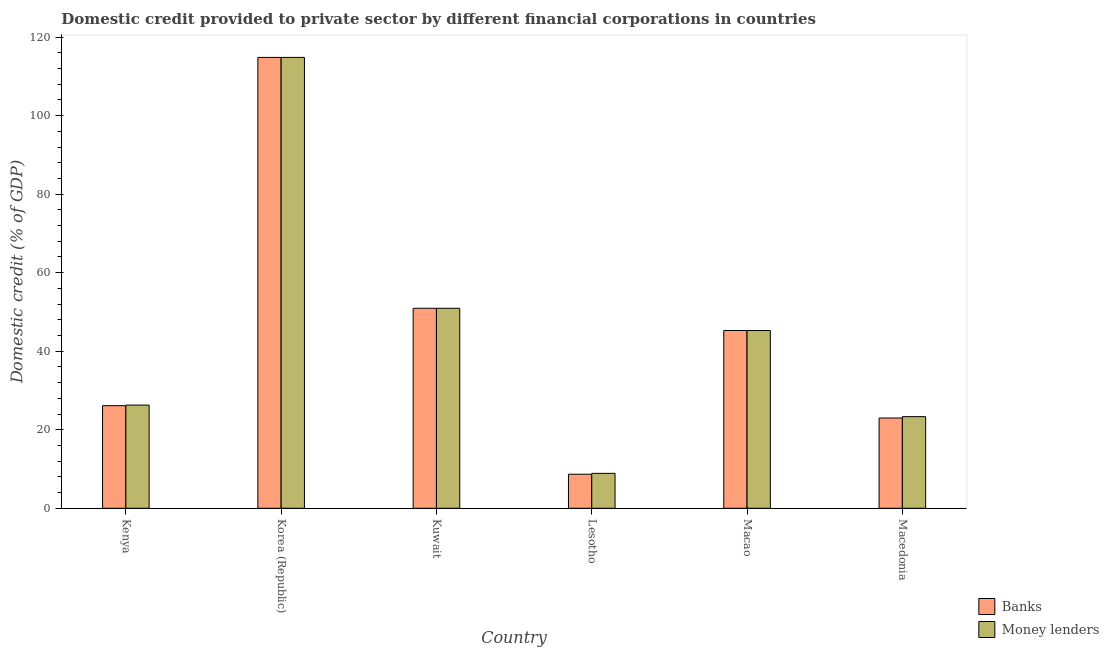How many different coloured bars are there?
Offer a very short reply. 2. Are the number of bars per tick equal to the number of legend labels?
Provide a short and direct response. Yes. Are the number of bars on each tick of the X-axis equal?
Provide a succinct answer. Yes. How many bars are there on the 4th tick from the right?
Your answer should be compact. 2. What is the label of the 5th group of bars from the left?
Give a very brief answer. Macao. What is the domestic credit provided by banks in Kenya?
Your response must be concise. 26.13. Across all countries, what is the maximum domestic credit provided by money lenders?
Provide a short and direct response. 114.82. Across all countries, what is the minimum domestic credit provided by money lenders?
Give a very brief answer. 8.89. In which country was the domestic credit provided by money lenders maximum?
Keep it short and to the point. Korea (Republic). In which country was the domestic credit provided by banks minimum?
Give a very brief answer. Lesotho. What is the total domestic credit provided by banks in the graph?
Provide a succinct answer. 268.81. What is the difference between the domestic credit provided by banks in Kenya and that in Macao?
Your answer should be very brief. -19.14. What is the difference between the domestic credit provided by money lenders in Kenya and the domestic credit provided by banks in Kuwait?
Keep it short and to the point. -24.66. What is the average domestic credit provided by money lenders per country?
Your answer should be very brief. 44.92. In how many countries, is the domestic credit provided by money lenders greater than 80 %?
Provide a succinct answer. 1. What is the ratio of the domestic credit provided by banks in Lesotho to that in Macao?
Offer a very short reply. 0.19. Is the domestic credit provided by banks in Kuwait less than that in Macao?
Your answer should be compact. No. What is the difference between the highest and the second highest domestic credit provided by money lenders?
Your answer should be compact. 63.89. What is the difference between the highest and the lowest domestic credit provided by money lenders?
Provide a short and direct response. 105.93. In how many countries, is the domestic credit provided by money lenders greater than the average domestic credit provided by money lenders taken over all countries?
Your response must be concise. 3. What does the 2nd bar from the left in Lesotho represents?
Offer a terse response. Money lenders. What does the 2nd bar from the right in Macao represents?
Your answer should be very brief. Banks. What is the difference between two consecutive major ticks on the Y-axis?
Offer a very short reply. 20. Are the values on the major ticks of Y-axis written in scientific E-notation?
Your answer should be very brief. No. What is the title of the graph?
Keep it short and to the point. Domestic credit provided to private sector by different financial corporations in countries. What is the label or title of the X-axis?
Give a very brief answer. Country. What is the label or title of the Y-axis?
Offer a very short reply. Domestic credit (% of GDP). What is the Domestic credit (% of GDP) in Banks in Kenya?
Your answer should be very brief. 26.13. What is the Domestic credit (% of GDP) of Money lenders in Kenya?
Your answer should be compact. 26.28. What is the Domestic credit (% of GDP) in Banks in Korea (Republic)?
Provide a short and direct response. 114.82. What is the Domestic credit (% of GDP) of Money lenders in Korea (Republic)?
Your answer should be very brief. 114.82. What is the Domestic credit (% of GDP) of Banks in Kuwait?
Your answer should be compact. 50.93. What is the Domestic credit (% of GDP) in Money lenders in Kuwait?
Your response must be concise. 50.93. What is the Domestic credit (% of GDP) of Banks in Lesotho?
Provide a succinct answer. 8.67. What is the Domestic credit (% of GDP) in Money lenders in Lesotho?
Your answer should be very brief. 8.89. What is the Domestic credit (% of GDP) of Banks in Macao?
Your answer should be very brief. 45.27. What is the Domestic credit (% of GDP) in Money lenders in Macao?
Ensure brevity in your answer.  45.27. What is the Domestic credit (% of GDP) of Banks in Macedonia?
Offer a very short reply. 22.99. What is the Domestic credit (% of GDP) in Money lenders in Macedonia?
Keep it short and to the point. 23.33. Across all countries, what is the maximum Domestic credit (% of GDP) in Banks?
Offer a very short reply. 114.82. Across all countries, what is the maximum Domestic credit (% of GDP) in Money lenders?
Offer a very short reply. 114.82. Across all countries, what is the minimum Domestic credit (% of GDP) in Banks?
Offer a very short reply. 8.67. Across all countries, what is the minimum Domestic credit (% of GDP) in Money lenders?
Keep it short and to the point. 8.89. What is the total Domestic credit (% of GDP) in Banks in the graph?
Your answer should be very brief. 268.81. What is the total Domestic credit (% of GDP) of Money lenders in the graph?
Your response must be concise. 269.52. What is the difference between the Domestic credit (% of GDP) of Banks in Kenya and that in Korea (Republic)?
Keep it short and to the point. -88.69. What is the difference between the Domestic credit (% of GDP) of Money lenders in Kenya and that in Korea (Republic)?
Provide a succinct answer. -88.54. What is the difference between the Domestic credit (% of GDP) of Banks in Kenya and that in Kuwait?
Your answer should be compact. -24.8. What is the difference between the Domestic credit (% of GDP) of Money lenders in Kenya and that in Kuwait?
Your response must be concise. -24.66. What is the difference between the Domestic credit (% of GDP) in Banks in Kenya and that in Lesotho?
Your answer should be very brief. 17.46. What is the difference between the Domestic credit (% of GDP) in Money lenders in Kenya and that in Lesotho?
Provide a succinct answer. 17.38. What is the difference between the Domestic credit (% of GDP) in Banks in Kenya and that in Macao?
Provide a succinct answer. -19.14. What is the difference between the Domestic credit (% of GDP) of Money lenders in Kenya and that in Macao?
Ensure brevity in your answer.  -18.99. What is the difference between the Domestic credit (% of GDP) in Banks in Kenya and that in Macedonia?
Keep it short and to the point. 3.14. What is the difference between the Domestic credit (% of GDP) of Money lenders in Kenya and that in Macedonia?
Keep it short and to the point. 2.94. What is the difference between the Domestic credit (% of GDP) of Banks in Korea (Republic) and that in Kuwait?
Make the answer very short. 63.89. What is the difference between the Domestic credit (% of GDP) in Money lenders in Korea (Republic) and that in Kuwait?
Your response must be concise. 63.89. What is the difference between the Domestic credit (% of GDP) of Banks in Korea (Republic) and that in Lesotho?
Provide a short and direct response. 106.15. What is the difference between the Domestic credit (% of GDP) of Money lenders in Korea (Republic) and that in Lesotho?
Give a very brief answer. 105.93. What is the difference between the Domestic credit (% of GDP) in Banks in Korea (Republic) and that in Macao?
Give a very brief answer. 69.55. What is the difference between the Domestic credit (% of GDP) of Money lenders in Korea (Republic) and that in Macao?
Your answer should be compact. 69.55. What is the difference between the Domestic credit (% of GDP) in Banks in Korea (Republic) and that in Macedonia?
Your answer should be very brief. 91.83. What is the difference between the Domestic credit (% of GDP) in Money lenders in Korea (Republic) and that in Macedonia?
Your response must be concise. 91.49. What is the difference between the Domestic credit (% of GDP) of Banks in Kuwait and that in Lesotho?
Offer a terse response. 42.26. What is the difference between the Domestic credit (% of GDP) in Money lenders in Kuwait and that in Lesotho?
Give a very brief answer. 42.04. What is the difference between the Domestic credit (% of GDP) of Banks in Kuwait and that in Macao?
Offer a very short reply. 5.66. What is the difference between the Domestic credit (% of GDP) in Money lenders in Kuwait and that in Macao?
Offer a very short reply. 5.66. What is the difference between the Domestic credit (% of GDP) of Banks in Kuwait and that in Macedonia?
Your response must be concise. 27.95. What is the difference between the Domestic credit (% of GDP) in Money lenders in Kuwait and that in Macedonia?
Provide a short and direct response. 27.6. What is the difference between the Domestic credit (% of GDP) in Banks in Lesotho and that in Macao?
Your response must be concise. -36.6. What is the difference between the Domestic credit (% of GDP) of Money lenders in Lesotho and that in Macao?
Provide a succinct answer. -36.38. What is the difference between the Domestic credit (% of GDP) of Banks in Lesotho and that in Macedonia?
Your response must be concise. -14.32. What is the difference between the Domestic credit (% of GDP) of Money lenders in Lesotho and that in Macedonia?
Ensure brevity in your answer.  -14.44. What is the difference between the Domestic credit (% of GDP) of Banks in Macao and that in Macedonia?
Your answer should be very brief. 22.28. What is the difference between the Domestic credit (% of GDP) in Money lenders in Macao and that in Macedonia?
Ensure brevity in your answer.  21.94. What is the difference between the Domestic credit (% of GDP) in Banks in Kenya and the Domestic credit (% of GDP) in Money lenders in Korea (Republic)?
Give a very brief answer. -88.69. What is the difference between the Domestic credit (% of GDP) in Banks in Kenya and the Domestic credit (% of GDP) in Money lenders in Kuwait?
Your answer should be compact. -24.8. What is the difference between the Domestic credit (% of GDP) in Banks in Kenya and the Domestic credit (% of GDP) in Money lenders in Lesotho?
Provide a short and direct response. 17.24. What is the difference between the Domestic credit (% of GDP) in Banks in Kenya and the Domestic credit (% of GDP) in Money lenders in Macao?
Your answer should be compact. -19.14. What is the difference between the Domestic credit (% of GDP) of Banks in Kenya and the Domestic credit (% of GDP) of Money lenders in Macedonia?
Ensure brevity in your answer.  2.8. What is the difference between the Domestic credit (% of GDP) in Banks in Korea (Republic) and the Domestic credit (% of GDP) in Money lenders in Kuwait?
Your answer should be very brief. 63.89. What is the difference between the Domestic credit (% of GDP) of Banks in Korea (Republic) and the Domestic credit (% of GDP) of Money lenders in Lesotho?
Provide a short and direct response. 105.93. What is the difference between the Domestic credit (% of GDP) of Banks in Korea (Republic) and the Domestic credit (% of GDP) of Money lenders in Macao?
Your response must be concise. 69.55. What is the difference between the Domestic credit (% of GDP) of Banks in Korea (Republic) and the Domestic credit (% of GDP) of Money lenders in Macedonia?
Your response must be concise. 91.49. What is the difference between the Domestic credit (% of GDP) of Banks in Kuwait and the Domestic credit (% of GDP) of Money lenders in Lesotho?
Make the answer very short. 42.04. What is the difference between the Domestic credit (% of GDP) in Banks in Kuwait and the Domestic credit (% of GDP) in Money lenders in Macao?
Provide a short and direct response. 5.66. What is the difference between the Domestic credit (% of GDP) of Banks in Kuwait and the Domestic credit (% of GDP) of Money lenders in Macedonia?
Give a very brief answer. 27.6. What is the difference between the Domestic credit (% of GDP) of Banks in Lesotho and the Domestic credit (% of GDP) of Money lenders in Macao?
Make the answer very short. -36.6. What is the difference between the Domestic credit (% of GDP) of Banks in Lesotho and the Domestic credit (% of GDP) of Money lenders in Macedonia?
Offer a terse response. -14.66. What is the difference between the Domestic credit (% of GDP) in Banks in Macao and the Domestic credit (% of GDP) in Money lenders in Macedonia?
Give a very brief answer. 21.94. What is the average Domestic credit (% of GDP) in Banks per country?
Provide a succinct answer. 44.8. What is the average Domestic credit (% of GDP) in Money lenders per country?
Your response must be concise. 44.92. What is the difference between the Domestic credit (% of GDP) in Banks and Domestic credit (% of GDP) in Money lenders in Kenya?
Give a very brief answer. -0.15. What is the difference between the Domestic credit (% of GDP) in Banks and Domestic credit (% of GDP) in Money lenders in Kuwait?
Your response must be concise. 0. What is the difference between the Domestic credit (% of GDP) in Banks and Domestic credit (% of GDP) in Money lenders in Lesotho?
Offer a very short reply. -0.22. What is the difference between the Domestic credit (% of GDP) in Banks and Domestic credit (% of GDP) in Money lenders in Macao?
Offer a terse response. 0. What is the difference between the Domestic credit (% of GDP) in Banks and Domestic credit (% of GDP) in Money lenders in Macedonia?
Your answer should be compact. -0.34. What is the ratio of the Domestic credit (% of GDP) of Banks in Kenya to that in Korea (Republic)?
Offer a very short reply. 0.23. What is the ratio of the Domestic credit (% of GDP) of Money lenders in Kenya to that in Korea (Republic)?
Offer a terse response. 0.23. What is the ratio of the Domestic credit (% of GDP) in Banks in Kenya to that in Kuwait?
Provide a succinct answer. 0.51. What is the ratio of the Domestic credit (% of GDP) of Money lenders in Kenya to that in Kuwait?
Offer a very short reply. 0.52. What is the ratio of the Domestic credit (% of GDP) in Banks in Kenya to that in Lesotho?
Ensure brevity in your answer.  3.01. What is the ratio of the Domestic credit (% of GDP) of Money lenders in Kenya to that in Lesotho?
Your response must be concise. 2.95. What is the ratio of the Domestic credit (% of GDP) in Banks in Kenya to that in Macao?
Provide a short and direct response. 0.58. What is the ratio of the Domestic credit (% of GDP) in Money lenders in Kenya to that in Macao?
Provide a short and direct response. 0.58. What is the ratio of the Domestic credit (% of GDP) in Banks in Kenya to that in Macedonia?
Your answer should be compact. 1.14. What is the ratio of the Domestic credit (% of GDP) of Money lenders in Kenya to that in Macedonia?
Ensure brevity in your answer.  1.13. What is the ratio of the Domestic credit (% of GDP) of Banks in Korea (Republic) to that in Kuwait?
Ensure brevity in your answer.  2.25. What is the ratio of the Domestic credit (% of GDP) in Money lenders in Korea (Republic) to that in Kuwait?
Offer a very short reply. 2.25. What is the ratio of the Domestic credit (% of GDP) of Banks in Korea (Republic) to that in Lesotho?
Your answer should be very brief. 13.24. What is the ratio of the Domestic credit (% of GDP) of Money lenders in Korea (Republic) to that in Lesotho?
Your answer should be compact. 12.91. What is the ratio of the Domestic credit (% of GDP) of Banks in Korea (Republic) to that in Macao?
Offer a very short reply. 2.54. What is the ratio of the Domestic credit (% of GDP) of Money lenders in Korea (Republic) to that in Macao?
Give a very brief answer. 2.54. What is the ratio of the Domestic credit (% of GDP) of Banks in Korea (Republic) to that in Macedonia?
Keep it short and to the point. 4.99. What is the ratio of the Domestic credit (% of GDP) of Money lenders in Korea (Republic) to that in Macedonia?
Provide a short and direct response. 4.92. What is the ratio of the Domestic credit (% of GDP) of Banks in Kuwait to that in Lesotho?
Your response must be concise. 5.88. What is the ratio of the Domestic credit (% of GDP) in Money lenders in Kuwait to that in Lesotho?
Your response must be concise. 5.73. What is the ratio of the Domestic credit (% of GDP) of Banks in Kuwait to that in Macao?
Provide a short and direct response. 1.13. What is the ratio of the Domestic credit (% of GDP) in Money lenders in Kuwait to that in Macao?
Offer a terse response. 1.13. What is the ratio of the Domestic credit (% of GDP) in Banks in Kuwait to that in Macedonia?
Provide a succinct answer. 2.22. What is the ratio of the Domestic credit (% of GDP) of Money lenders in Kuwait to that in Macedonia?
Your response must be concise. 2.18. What is the ratio of the Domestic credit (% of GDP) in Banks in Lesotho to that in Macao?
Provide a short and direct response. 0.19. What is the ratio of the Domestic credit (% of GDP) of Money lenders in Lesotho to that in Macao?
Offer a terse response. 0.2. What is the ratio of the Domestic credit (% of GDP) of Banks in Lesotho to that in Macedonia?
Your answer should be compact. 0.38. What is the ratio of the Domestic credit (% of GDP) in Money lenders in Lesotho to that in Macedonia?
Your response must be concise. 0.38. What is the ratio of the Domestic credit (% of GDP) in Banks in Macao to that in Macedonia?
Offer a terse response. 1.97. What is the ratio of the Domestic credit (% of GDP) in Money lenders in Macao to that in Macedonia?
Provide a succinct answer. 1.94. What is the difference between the highest and the second highest Domestic credit (% of GDP) in Banks?
Make the answer very short. 63.89. What is the difference between the highest and the second highest Domestic credit (% of GDP) in Money lenders?
Your response must be concise. 63.89. What is the difference between the highest and the lowest Domestic credit (% of GDP) of Banks?
Provide a short and direct response. 106.15. What is the difference between the highest and the lowest Domestic credit (% of GDP) in Money lenders?
Offer a very short reply. 105.93. 